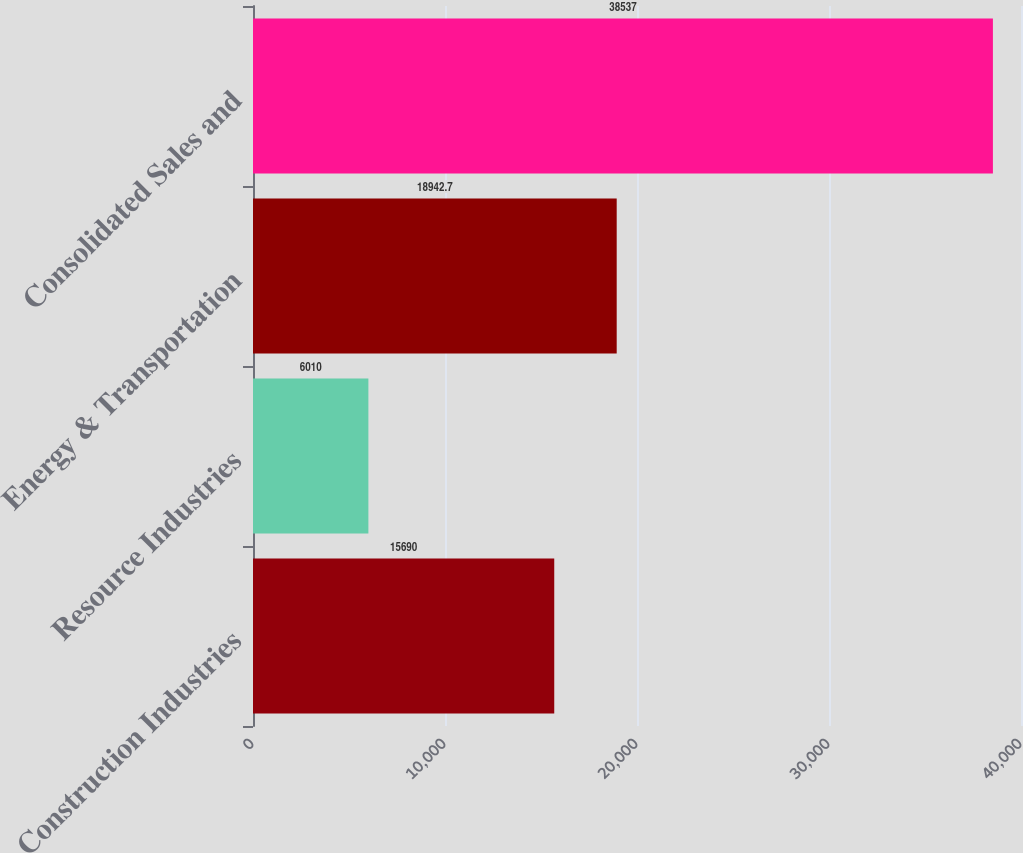Convert chart. <chart><loc_0><loc_0><loc_500><loc_500><bar_chart><fcel>Construction Industries<fcel>Resource Industries<fcel>Energy & Transportation<fcel>Consolidated Sales and<nl><fcel>15690<fcel>6010<fcel>18942.7<fcel>38537<nl></chart> 